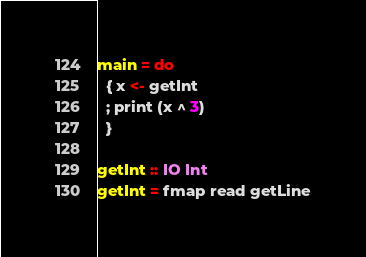Convert code to text. <code><loc_0><loc_0><loc_500><loc_500><_Haskell_>main = do
  { x <- getInt
  ; print (x ^ 3)
  }

getInt :: IO Int
getInt = fmap read getLine


</code> 